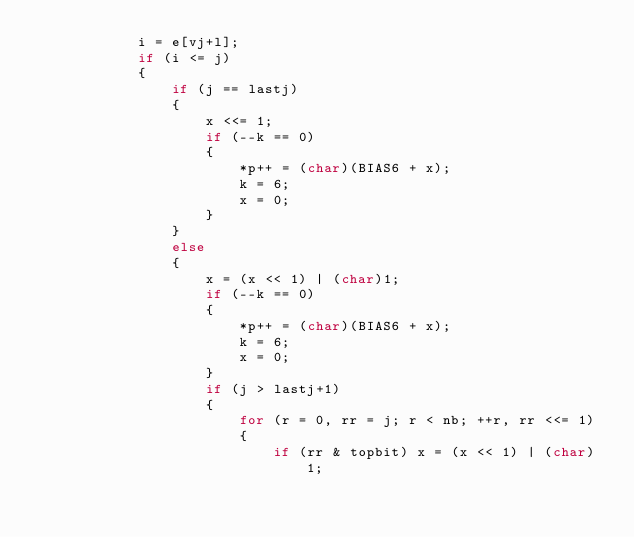Convert code to text. <code><loc_0><loc_0><loc_500><loc_500><_C_>            i = e[vj+l];
            if (i <= j)
            {
                if (j == lastj)
                {
                    x <<= 1;
                    if (--k == 0)
                    {
                        *p++ = (char)(BIAS6 + x);
                        k = 6;
                        x = 0;
                    }
                }
                else
                {
                    x = (x << 1) | (char)1;
                    if (--k == 0)
                    {
                        *p++ = (char)(BIAS6 + x);
                        k = 6;
                        x = 0;
                    }
                    if (j > lastj+1)
                    {
                        for (r = 0, rr = j; r < nb; ++r, rr <<= 1)
                        {
                            if (rr & topbit) x = (x << 1) | (char)1;</code> 